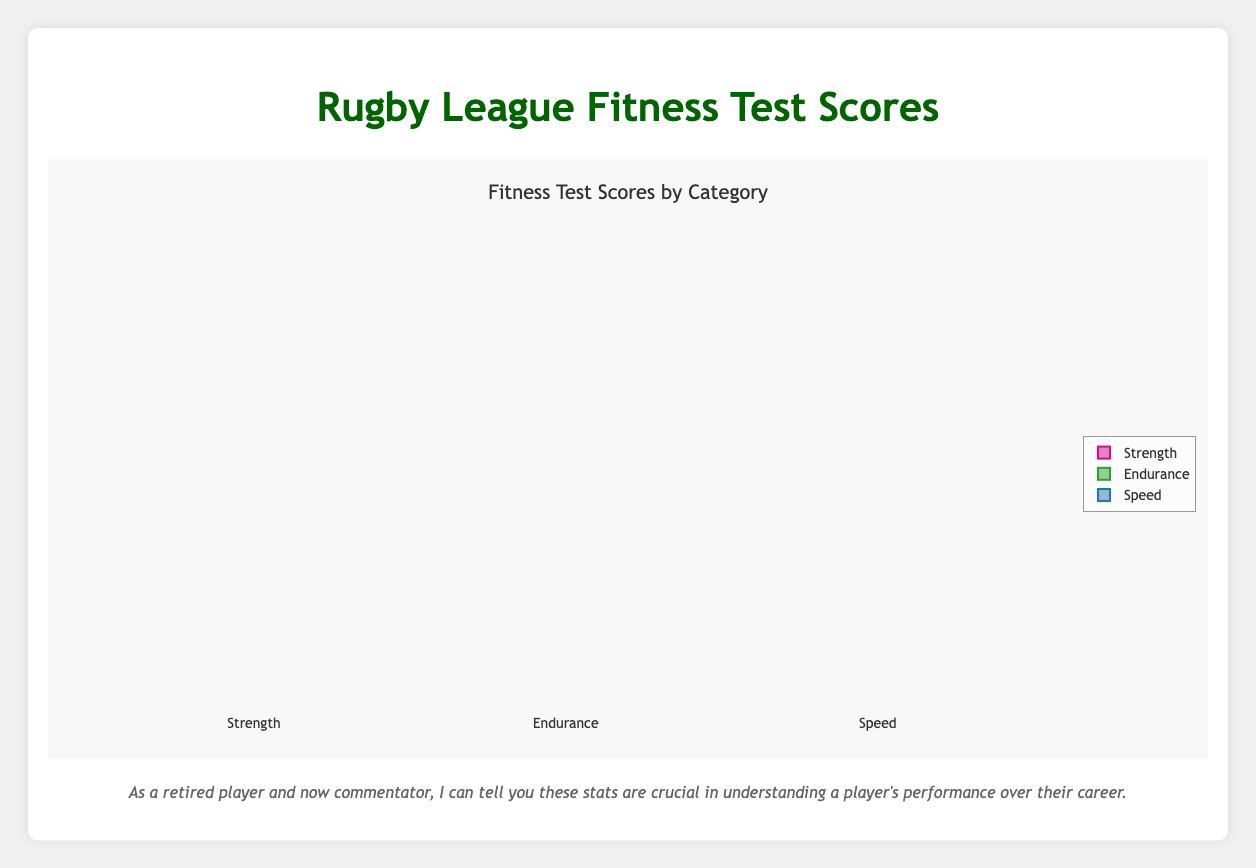How many different categories of fitness tests are shown? The figure shows box plots grouped by three categories: Strength, Endurance, and Speed.
Answer: 3 What is the title of the figure? The title of the figure is displayed at the top, indicating the content being visualized.
Answer: Fitness Test Scores by Category Which player shows the highest median Speed score? The box plot for Speed shows individual player points. By identifying the highest median line in the Speed category, we see Billy Slater's scores are highest.
Answer: Billy Slater What is the range of the Strength scores for Cameron Smith? The box plot's range for Cameron Smith's Strength scores can be observed between the minimum and maximum values displayed.
Answer: 85 to 90 Which fitness test category has the widest interquartile range (IQR) for Paul Gallen? For Paul Gallen, examine the distance between the first and third quartiles (IQR) in each box plot for Strength, Endurance, and Speed.
Answer: Strength Compare the median Endurance scores of Darren Lockyer and Cameron Smith. Which one is higher? Look at the median line within the Endurance category for both Darren Lockyer and Cameron Smith. Darren's median is 90, while Cameron's median is 91.
Answer: Cameron Smith Which player has the smallest range in the Strength scores? The smallest range can be identified by the shortest distance between the minimum and maximum values in the Strength category.
Answer: Johnathan Thurston What is the median Strength score for Greg Inglis? Identify the middle line in the box plot for Greg Inglis in the Strength category.
Answer: 88 What is the maximum Speed score for Sam Thaiday? Look for the maximum data point in the Speed category box plot for Sam Thaiday.
Answer: 80 Compare the interquartile ranges (IQR) of Speed for Greg Inglis and Justin Hodges. Which one has a larger IQR? Calculate the IQR by subtracting the value at the first quartile (Q1) from the third quartile (Q3) for both players in the Speed category. Greg Inglis' IQR is larger.
Answer: Greg Inglis 